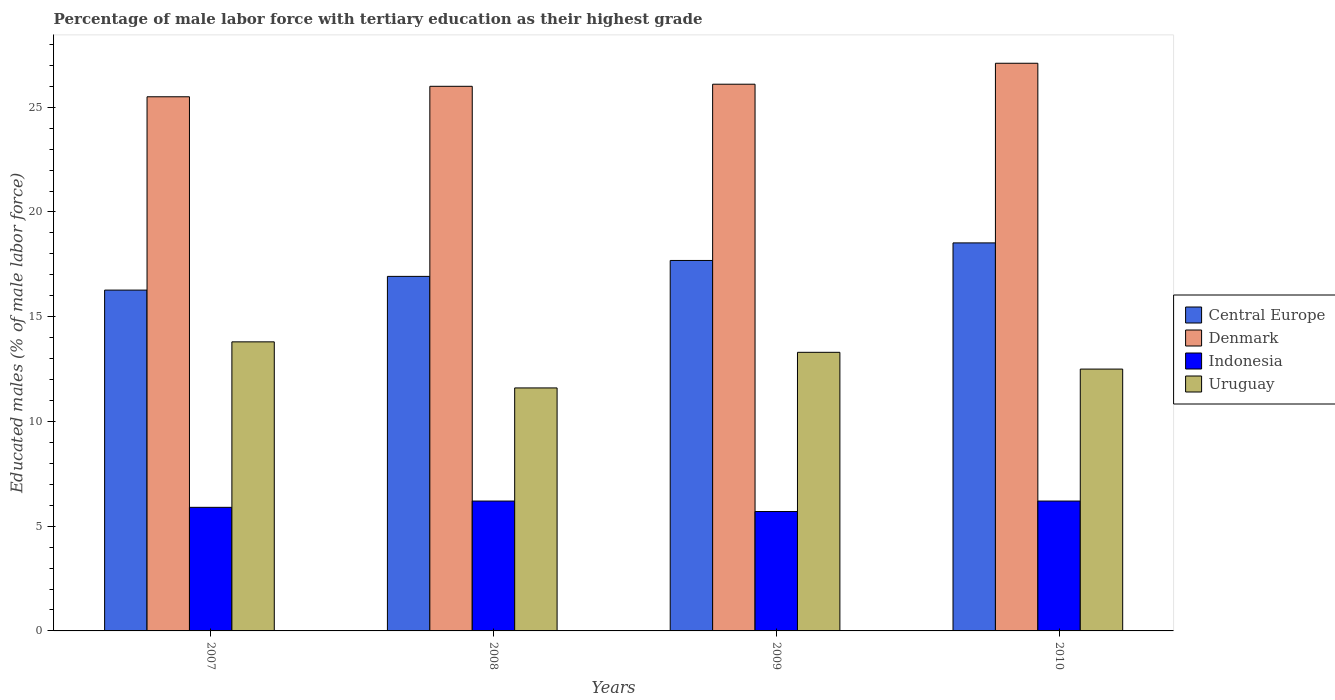How many different coloured bars are there?
Ensure brevity in your answer.  4. How many groups of bars are there?
Keep it short and to the point. 4. Are the number of bars per tick equal to the number of legend labels?
Make the answer very short. Yes. What is the percentage of male labor force with tertiary education in Uruguay in 2007?
Keep it short and to the point. 13.8. Across all years, what is the maximum percentage of male labor force with tertiary education in Indonesia?
Ensure brevity in your answer.  6.2. Across all years, what is the minimum percentage of male labor force with tertiary education in Uruguay?
Provide a succinct answer. 11.6. In which year was the percentage of male labor force with tertiary education in Denmark maximum?
Offer a very short reply. 2010. What is the total percentage of male labor force with tertiary education in Indonesia in the graph?
Give a very brief answer. 24. What is the difference between the percentage of male labor force with tertiary education in Central Europe in 2007 and that in 2009?
Give a very brief answer. -1.41. What is the difference between the percentage of male labor force with tertiary education in Indonesia in 2007 and the percentage of male labor force with tertiary education in Denmark in 2009?
Ensure brevity in your answer.  -20.2. What is the average percentage of male labor force with tertiary education in Indonesia per year?
Your answer should be compact. 6. In the year 2008, what is the difference between the percentage of male labor force with tertiary education in Denmark and percentage of male labor force with tertiary education in Uruguay?
Provide a short and direct response. 14.4. In how many years, is the percentage of male labor force with tertiary education in Uruguay greater than 20 %?
Your response must be concise. 0. What is the ratio of the percentage of male labor force with tertiary education in Uruguay in 2007 to that in 2009?
Provide a short and direct response. 1.04. Is the percentage of male labor force with tertiary education in Central Europe in 2008 less than that in 2009?
Provide a succinct answer. Yes. What is the difference between the highest and the second highest percentage of male labor force with tertiary education in Central Europe?
Keep it short and to the point. 0.84. What is the difference between the highest and the lowest percentage of male labor force with tertiary education in Uruguay?
Offer a very short reply. 2.2. Is the sum of the percentage of male labor force with tertiary education in Uruguay in 2008 and 2009 greater than the maximum percentage of male labor force with tertiary education in Indonesia across all years?
Offer a very short reply. Yes. What does the 1st bar from the right in 2010 represents?
Make the answer very short. Uruguay. Are all the bars in the graph horizontal?
Your response must be concise. No. What is the difference between two consecutive major ticks on the Y-axis?
Give a very brief answer. 5. Are the values on the major ticks of Y-axis written in scientific E-notation?
Your response must be concise. No. How are the legend labels stacked?
Make the answer very short. Vertical. What is the title of the graph?
Your answer should be very brief. Percentage of male labor force with tertiary education as their highest grade. What is the label or title of the Y-axis?
Provide a succinct answer. Educated males (% of male labor force). What is the Educated males (% of male labor force) of Central Europe in 2007?
Your answer should be very brief. 16.27. What is the Educated males (% of male labor force) in Indonesia in 2007?
Offer a very short reply. 5.9. What is the Educated males (% of male labor force) of Uruguay in 2007?
Your answer should be very brief. 13.8. What is the Educated males (% of male labor force) of Central Europe in 2008?
Provide a short and direct response. 16.93. What is the Educated males (% of male labor force) in Denmark in 2008?
Your answer should be very brief. 26. What is the Educated males (% of male labor force) in Indonesia in 2008?
Offer a terse response. 6.2. What is the Educated males (% of male labor force) in Uruguay in 2008?
Provide a short and direct response. 11.6. What is the Educated males (% of male labor force) of Central Europe in 2009?
Keep it short and to the point. 17.69. What is the Educated males (% of male labor force) of Denmark in 2009?
Offer a terse response. 26.1. What is the Educated males (% of male labor force) in Indonesia in 2009?
Keep it short and to the point. 5.7. What is the Educated males (% of male labor force) in Uruguay in 2009?
Offer a very short reply. 13.3. What is the Educated males (% of male labor force) in Central Europe in 2010?
Make the answer very short. 18.52. What is the Educated males (% of male labor force) of Denmark in 2010?
Keep it short and to the point. 27.1. What is the Educated males (% of male labor force) in Indonesia in 2010?
Offer a terse response. 6.2. What is the Educated males (% of male labor force) in Uruguay in 2010?
Your answer should be very brief. 12.5. Across all years, what is the maximum Educated males (% of male labor force) of Central Europe?
Ensure brevity in your answer.  18.52. Across all years, what is the maximum Educated males (% of male labor force) in Denmark?
Your response must be concise. 27.1. Across all years, what is the maximum Educated males (% of male labor force) in Indonesia?
Make the answer very short. 6.2. Across all years, what is the maximum Educated males (% of male labor force) of Uruguay?
Ensure brevity in your answer.  13.8. Across all years, what is the minimum Educated males (% of male labor force) of Central Europe?
Provide a succinct answer. 16.27. Across all years, what is the minimum Educated males (% of male labor force) of Indonesia?
Offer a terse response. 5.7. Across all years, what is the minimum Educated males (% of male labor force) in Uruguay?
Give a very brief answer. 11.6. What is the total Educated males (% of male labor force) of Central Europe in the graph?
Provide a succinct answer. 69.41. What is the total Educated males (% of male labor force) in Denmark in the graph?
Provide a short and direct response. 104.7. What is the total Educated males (% of male labor force) in Uruguay in the graph?
Keep it short and to the point. 51.2. What is the difference between the Educated males (% of male labor force) of Central Europe in 2007 and that in 2008?
Keep it short and to the point. -0.66. What is the difference between the Educated males (% of male labor force) of Denmark in 2007 and that in 2008?
Give a very brief answer. -0.5. What is the difference between the Educated males (% of male labor force) in Central Europe in 2007 and that in 2009?
Keep it short and to the point. -1.42. What is the difference between the Educated males (% of male labor force) of Denmark in 2007 and that in 2009?
Your response must be concise. -0.6. What is the difference between the Educated males (% of male labor force) in Indonesia in 2007 and that in 2009?
Your response must be concise. 0.2. What is the difference between the Educated males (% of male labor force) of Uruguay in 2007 and that in 2009?
Provide a short and direct response. 0.5. What is the difference between the Educated males (% of male labor force) in Central Europe in 2007 and that in 2010?
Offer a very short reply. -2.25. What is the difference between the Educated males (% of male labor force) in Denmark in 2007 and that in 2010?
Make the answer very short. -1.6. What is the difference between the Educated males (% of male labor force) in Uruguay in 2007 and that in 2010?
Provide a succinct answer. 1.3. What is the difference between the Educated males (% of male labor force) of Central Europe in 2008 and that in 2009?
Your answer should be very brief. -0.76. What is the difference between the Educated males (% of male labor force) of Indonesia in 2008 and that in 2009?
Ensure brevity in your answer.  0.5. What is the difference between the Educated males (% of male labor force) in Central Europe in 2008 and that in 2010?
Your answer should be very brief. -1.6. What is the difference between the Educated males (% of male labor force) of Denmark in 2008 and that in 2010?
Provide a succinct answer. -1.1. What is the difference between the Educated males (% of male labor force) of Indonesia in 2008 and that in 2010?
Give a very brief answer. 0. What is the difference between the Educated males (% of male labor force) in Central Europe in 2009 and that in 2010?
Provide a short and direct response. -0.84. What is the difference between the Educated males (% of male labor force) in Denmark in 2009 and that in 2010?
Your answer should be compact. -1. What is the difference between the Educated males (% of male labor force) of Uruguay in 2009 and that in 2010?
Your response must be concise. 0.8. What is the difference between the Educated males (% of male labor force) in Central Europe in 2007 and the Educated males (% of male labor force) in Denmark in 2008?
Your answer should be very brief. -9.73. What is the difference between the Educated males (% of male labor force) in Central Europe in 2007 and the Educated males (% of male labor force) in Indonesia in 2008?
Keep it short and to the point. 10.07. What is the difference between the Educated males (% of male labor force) in Central Europe in 2007 and the Educated males (% of male labor force) in Uruguay in 2008?
Ensure brevity in your answer.  4.67. What is the difference between the Educated males (% of male labor force) of Denmark in 2007 and the Educated males (% of male labor force) of Indonesia in 2008?
Your response must be concise. 19.3. What is the difference between the Educated males (% of male labor force) in Central Europe in 2007 and the Educated males (% of male labor force) in Denmark in 2009?
Offer a very short reply. -9.83. What is the difference between the Educated males (% of male labor force) of Central Europe in 2007 and the Educated males (% of male labor force) of Indonesia in 2009?
Ensure brevity in your answer.  10.57. What is the difference between the Educated males (% of male labor force) in Central Europe in 2007 and the Educated males (% of male labor force) in Uruguay in 2009?
Give a very brief answer. 2.97. What is the difference between the Educated males (% of male labor force) in Denmark in 2007 and the Educated males (% of male labor force) in Indonesia in 2009?
Your answer should be very brief. 19.8. What is the difference between the Educated males (% of male labor force) in Central Europe in 2007 and the Educated males (% of male labor force) in Denmark in 2010?
Provide a succinct answer. -10.83. What is the difference between the Educated males (% of male labor force) in Central Europe in 2007 and the Educated males (% of male labor force) in Indonesia in 2010?
Ensure brevity in your answer.  10.07. What is the difference between the Educated males (% of male labor force) in Central Europe in 2007 and the Educated males (% of male labor force) in Uruguay in 2010?
Ensure brevity in your answer.  3.77. What is the difference between the Educated males (% of male labor force) of Denmark in 2007 and the Educated males (% of male labor force) of Indonesia in 2010?
Give a very brief answer. 19.3. What is the difference between the Educated males (% of male labor force) of Indonesia in 2007 and the Educated males (% of male labor force) of Uruguay in 2010?
Keep it short and to the point. -6.6. What is the difference between the Educated males (% of male labor force) of Central Europe in 2008 and the Educated males (% of male labor force) of Denmark in 2009?
Provide a short and direct response. -9.17. What is the difference between the Educated males (% of male labor force) of Central Europe in 2008 and the Educated males (% of male labor force) of Indonesia in 2009?
Ensure brevity in your answer.  11.23. What is the difference between the Educated males (% of male labor force) in Central Europe in 2008 and the Educated males (% of male labor force) in Uruguay in 2009?
Offer a very short reply. 3.63. What is the difference between the Educated males (% of male labor force) of Denmark in 2008 and the Educated males (% of male labor force) of Indonesia in 2009?
Ensure brevity in your answer.  20.3. What is the difference between the Educated males (% of male labor force) in Denmark in 2008 and the Educated males (% of male labor force) in Uruguay in 2009?
Offer a very short reply. 12.7. What is the difference between the Educated males (% of male labor force) in Central Europe in 2008 and the Educated males (% of male labor force) in Denmark in 2010?
Your response must be concise. -10.17. What is the difference between the Educated males (% of male labor force) in Central Europe in 2008 and the Educated males (% of male labor force) in Indonesia in 2010?
Provide a short and direct response. 10.73. What is the difference between the Educated males (% of male labor force) of Central Europe in 2008 and the Educated males (% of male labor force) of Uruguay in 2010?
Your answer should be very brief. 4.43. What is the difference between the Educated males (% of male labor force) of Denmark in 2008 and the Educated males (% of male labor force) of Indonesia in 2010?
Give a very brief answer. 19.8. What is the difference between the Educated males (% of male labor force) of Denmark in 2008 and the Educated males (% of male labor force) of Uruguay in 2010?
Your answer should be very brief. 13.5. What is the difference between the Educated males (% of male labor force) of Indonesia in 2008 and the Educated males (% of male labor force) of Uruguay in 2010?
Provide a succinct answer. -6.3. What is the difference between the Educated males (% of male labor force) of Central Europe in 2009 and the Educated males (% of male labor force) of Denmark in 2010?
Your answer should be very brief. -9.41. What is the difference between the Educated males (% of male labor force) of Central Europe in 2009 and the Educated males (% of male labor force) of Indonesia in 2010?
Your answer should be very brief. 11.49. What is the difference between the Educated males (% of male labor force) of Central Europe in 2009 and the Educated males (% of male labor force) of Uruguay in 2010?
Ensure brevity in your answer.  5.19. What is the difference between the Educated males (% of male labor force) of Denmark in 2009 and the Educated males (% of male labor force) of Uruguay in 2010?
Make the answer very short. 13.6. What is the average Educated males (% of male labor force) in Central Europe per year?
Offer a very short reply. 17.35. What is the average Educated males (% of male labor force) of Denmark per year?
Offer a very short reply. 26.18. What is the average Educated males (% of male labor force) in Indonesia per year?
Give a very brief answer. 6. In the year 2007, what is the difference between the Educated males (% of male labor force) in Central Europe and Educated males (% of male labor force) in Denmark?
Provide a short and direct response. -9.23. In the year 2007, what is the difference between the Educated males (% of male labor force) in Central Europe and Educated males (% of male labor force) in Indonesia?
Provide a succinct answer. 10.37. In the year 2007, what is the difference between the Educated males (% of male labor force) in Central Europe and Educated males (% of male labor force) in Uruguay?
Give a very brief answer. 2.47. In the year 2007, what is the difference between the Educated males (% of male labor force) of Denmark and Educated males (% of male labor force) of Indonesia?
Your answer should be compact. 19.6. In the year 2007, what is the difference between the Educated males (% of male labor force) in Denmark and Educated males (% of male labor force) in Uruguay?
Offer a very short reply. 11.7. In the year 2007, what is the difference between the Educated males (% of male labor force) of Indonesia and Educated males (% of male labor force) of Uruguay?
Provide a short and direct response. -7.9. In the year 2008, what is the difference between the Educated males (% of male labor force) of Central Europe and Educated males (% of male labor force) of Denmark?
Your answer should be compact. -9.07. In the year 2008, what is the difference between the Educated males (% of male labor force) of Central Europe and Educated males (% of male labor force) of Indonesia?
Provide a short and direct response. 10.73. In the year 2008, what is the difference between the Educated males (% of male labor force) in Central Europe and Educated males (% of male labor force) in Uruguay?
Make the answer very short. 5.33. In the year 2008, what is the difference between the Educated males (% of male labor force) in Denmark and Educated males (% of male labor force) in Indonesia?
Offer a very short reply. 19.8. In the year 2008, what is the difference between the Educated males (% of male labor force) of Indonesia and Educated males (% of male labor force) of Uruguay?
Provide a succinct answer. -5.4. In the year 2009, what is the difference between the Educated males (% of male labor force) of Central Europe and Educated males (% of male labor force) of Denmark?
Your answer should be compact. -8.41. In the year 2009, what is the difference between the Educated males (% of male labor force) in Central Europe and Educated males (% of male labor force) in Indonesia?
Ensure brevity in your answer.  11.99. In the year 2009, what is the difference between the Educated males (% of male labor force) in Central Europe and Educated males (% of male labor force) in Uruguay?
Keep it short and to the point. 4.39. In the year 2009, what is the difference between the Educated males (% of male labor force) of Denmark and Educated males (% of male labor force) of Indonesia?
Give a very brief answer. 20.4. In the year 2009, what is the difference between the Educated males (% of male labor force) in Denmark and Educated males (% of male labor force) in Uruguay?
Make the answer very short. 12.8. In the year 2010, what is the difference between the Educated males (% of male labor force) in Central Europe and Educated males (% of male labor force) in Denmark?
Your response must be concise. -8.58. In the year 2010, what is the difference between the Educated males (% of male labor force) in Central Europe and Educated males (% of male labor force) in Indonesia?
Offer a very short reply. 12.32. In the year 2010, what is the difference between the Educated males (% of male labor force) of Central Europe and Educated males (% of male labor force) of Uruguay?
Your answer should be compact. 6.02. In the year 2010, what is the difference between the Educated males (% of male labor force) in Denmark and Educated males (% of male labor force) in Indonesia?
Your response must be concise. 20.9. In the year 2010, what is the difference between the Educated males (% of male labor force) of Denmark and Educated males (% of male labor force) of Uruguay?
Make the answer very short. 14.6. What is the ratio of the Educated males (% of male labor force) in Central Europe in 2007 to that in 2008?
Provide a succinct answer. 0.96. What is the ratio of the Educated males (% of male labor force) in Denmark in 2007 to that in 2008?
Offer a very short reply. 0.98. What is the ratio of the Educated males (% of male labor force) of Indonesia in 2007 to that in 2008?
Your response must be concise. 0.95. What is the ratio of the Educated males (% of male labor force) of Uruguay in 2007 to that in 2008?
Offer a terse response. 1.19. What is the ratio of the Educated males (% of male labor force) in Denmark in 2007 to that in 2009?
Offer a very short reply. 0.98. What is the ratio of the Educated males (% of male labor force) in Indonesia in 2007 to that in 2009?
Provide a short and direct response. 1.04. What is the ratio of the Educated males (% of male labor force) in Uruguay in 2007 to that in 2009?
Offer a terse response. 1.04. What is the ratio of the Educated males (% of male labor force) in Central Europe in 2007 to that in 2010?
Make the answer very short. 0.88. What is the ratio of the Educated males (% of male labor force) in Denmark in 2007 to that in 2010?
Keep it short and to the point. 0.94. What is the ratio of the Educated males (% of male labor force) in Indonesia in 2007 to that in 2010?
Offer a very short reply. 0.95. What is the ratio of the Educated males (% of male labor force) in Uruguay in 2007 to that in 2010?
Make the answer very short. 1.1. What is the ratio of the Educated males (% of male labor force) in Central Europe in 2008 to that in 2009?
Your response must be concise. 0.96. What is the ratio of the Educated males (% of male labor force) of Denmark in 2008 to that in 2009?
Your response must be concise. 1. What is the ratio of the Educated males (% of male labor force) in Indonesia in 2008 to that in 2009?
Your answer should be compact. 1.09. What is the ratio of the Educated males (% of male labor force) in Uruguay in 2008 to that in 2009?
Your answer should be very brief. 0.87. What is the ratio of the Educated males (% of male labor force) of Central Europe in 2008 to that in 2010?
Offer a very short reply. 0.91. What is the ratio of the Educated males (% of male labor force) in Denmark in 2008 to that in 2010?
Give a very brief answer. 0.96. What is the ratio of the Educated males (% of male labor force) in Indonesia in 2008 to that in 2010?
Keep it short and to the point. 1. What is the ratio of the Educated males (% of male labor force) of Uruguay in 2008 to that in 2010?
Give a very brief answer. 0.93. What is the ratio of the Educated males (% of male labor force) of Central Europe in 2009 to that in 2010?
Provide a short and direct response. 0.95. What is the ratio of the Educated males (% of male labor force) in Denmark in 2009 to that in 2010?
Ensure brevity in your answer.  0.96. What is the ratio of the Educated males (% of male labor force) in Indonesia in 2009 to that in 2010?
Your answer should be very brief. 0.92. What is the ratio of the Educated males (% of male labor force) of Uruguay in 2009 to that in 2010?
Ensure brevity in your answer.  1.06. What is the difference between the highest and the second highest Educated males (% of male labor force) of Central Europe?
Ensure brevity in your answer.  0.84. What is the difference between the highest and the second highest Educated males (% of male labor force) of Uruguay?
Your answer should be compact. 0.5. What is the difference between the highest and the lowest Educated males (% of male labor force) in Central Europe?
Ensure brevity in your answer.  2.25. What is the difference between the highest and the lowest Educated males (% of male labor force) in Denmark?
Your response must be concise. 1.6. 